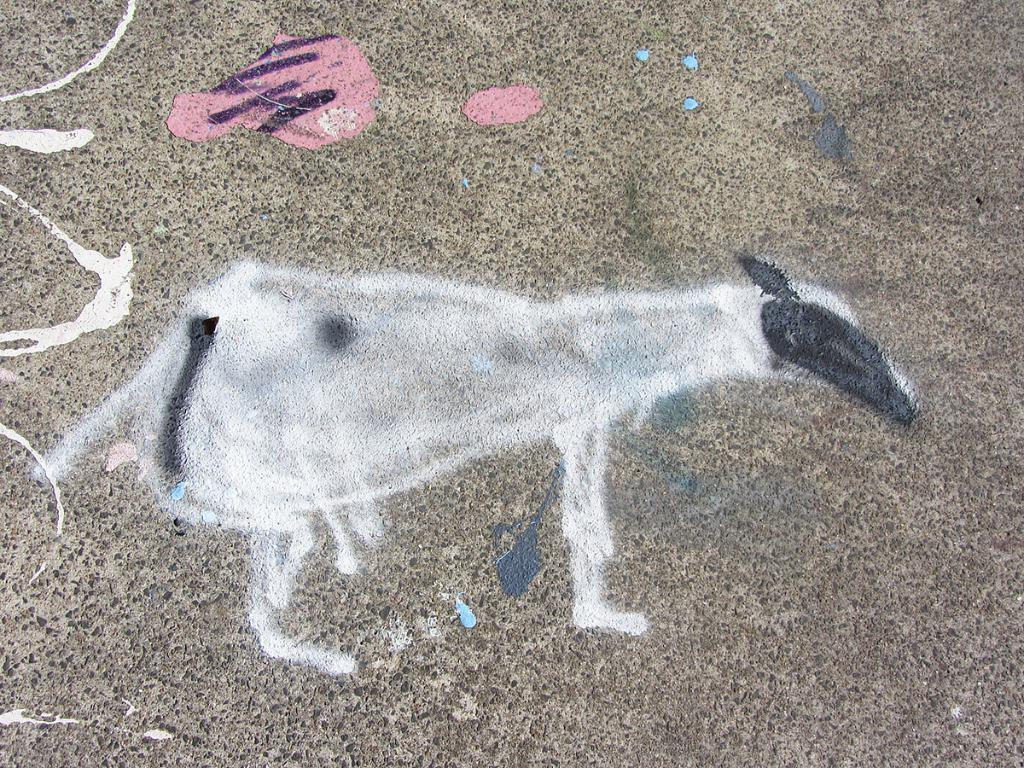What is depicted on the surface in the image? There is a painting on the surface in the image. What type of bone can be seen in the pocket of the person in the image? There is no person or bone present in the image; it only features a painting on a surface. 